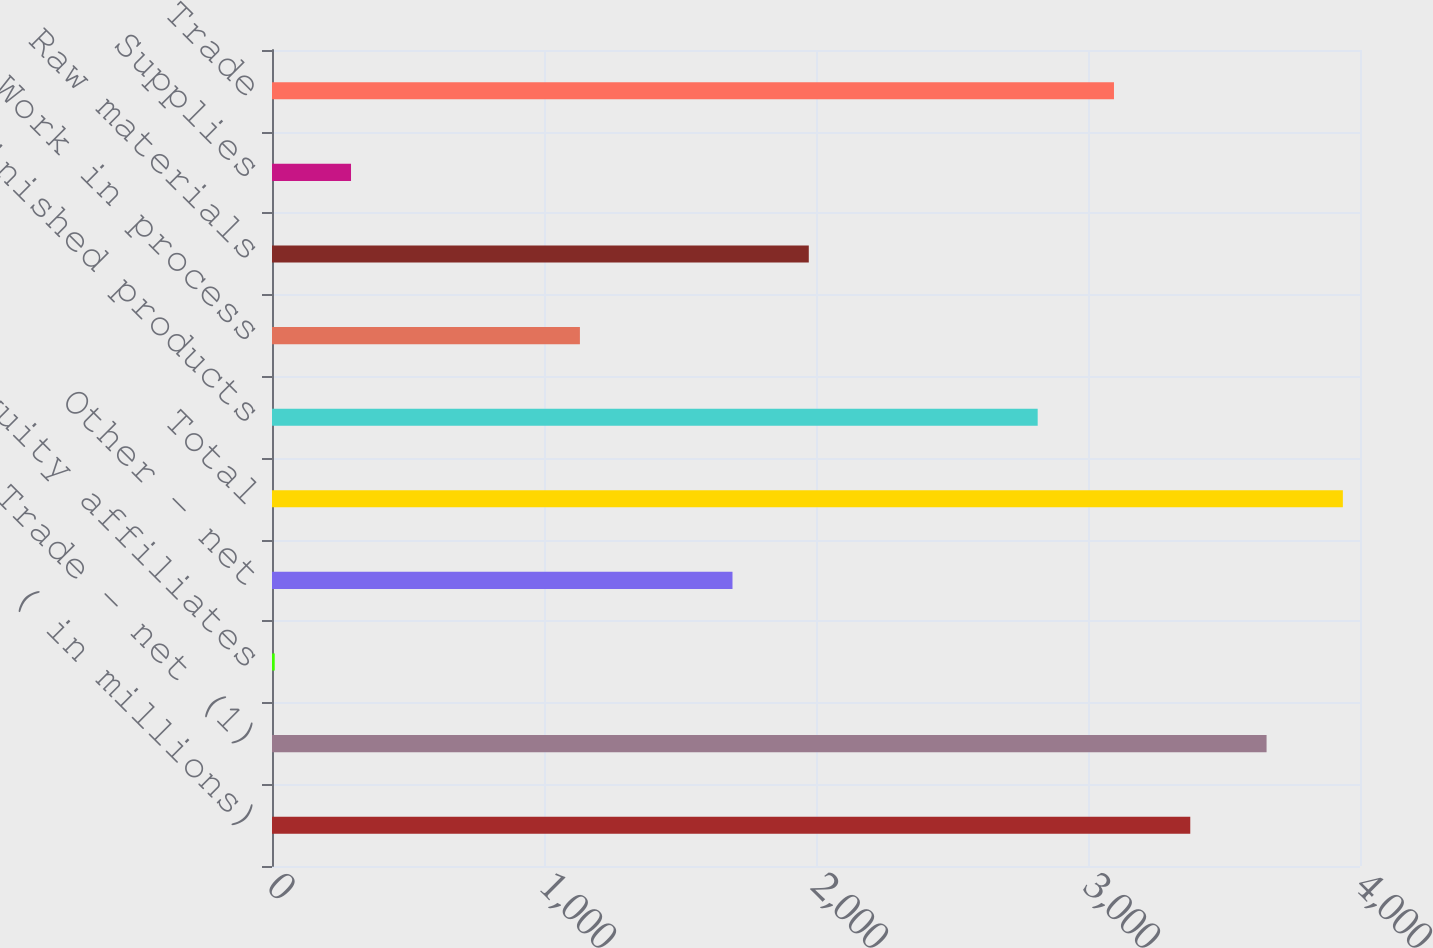Convert chart. <chart><loc_0><loc_0><loc_500><loc_500><bar_chart><fcel>( in millions)<fcel>Trade - net (1)<fcel>Equity affiliates<fcel>Other - net<fcel>Total<fcel>Finished products<fcel>Work in process<fcel>Raw materials<fcel>Supplies<fcel>Trade<nl><fcel>3376<fcel>3656.5<fcel>10<fcel>1693<fcel>3937<fcel>2815<fcel>1132<fcel>1973.5<fcel>290.5<fcel>3095.5<nl></chart> 